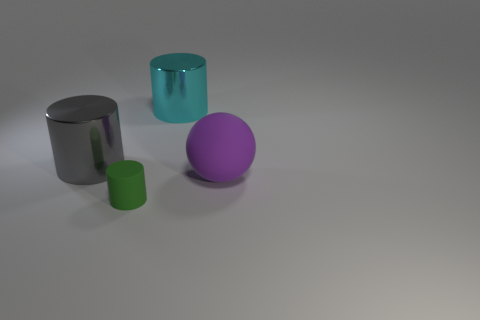What number of other things are the same size as the green matte cylinder?
Keep it short and to the point. 0. There is a large metallic cylinder that is behind the big gray cylinder; is it the same color as the tiny rubber cylinder?
Provide a succinct answer. No. Is the number of big cyan cylinders that are in front of the tiny rubber cylinder greater than the number of blue cylinders?
Offer a very short reply. No. Is there any other thing that is the same color as the matte sphere?
Provide a short and direct response. No. What shape is the thing behind the big metallic cylinder in front of the large cyan thing?
Provide a succinct answer. Cylinder. Is the number of tiny rubber cylinders greater than the number of cyan metallic balls?
Your answer should be compact. Yes. What number of cylinders are behind the purple sphere and in front of the large gray cylinder?
Provide a short and direct response. 0. There is a shiny cylinder to the right of the large gray metallic thing; how many things are to the left of it?
Provide a short and direct response. 2. What number of things are big things that are to the left of the large matte sphere or cylinders behind the large rubber thing?
Give a very brief answer. 2. There is a large cyan thing that is the same shape as the gray object; what is it made of?
Provide a short and direct response. Metal. 